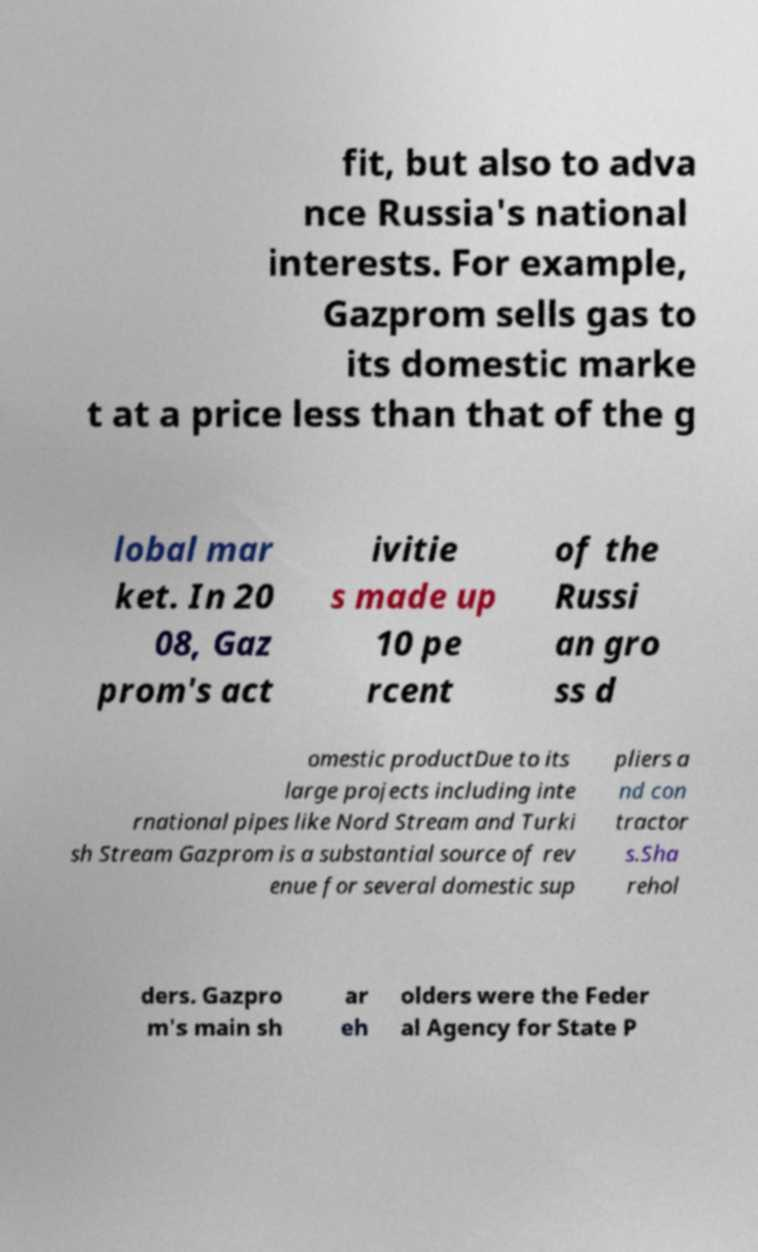Could you assist in decoding the text presented in this image and type it out clearly? fit, but also to adva nce Russia's national interests. For example, Gazprom sells gas to its domestic marke t at a price less than that of the g lobal mar ket. In 20 08, Gaz prom's act ivitie s made up 10 pe rcent of the Russi an gro ss d omestic productDue to its large projects including inte rnational pipes like Nord Stream and Turki sh Stream Gazprom is a substantial source of rev enue for several domestic sup pliers a nd con tractor s.Sha rehol ders. Gazpro m's main sh ar eh olders were the Feder al Agency for State P 